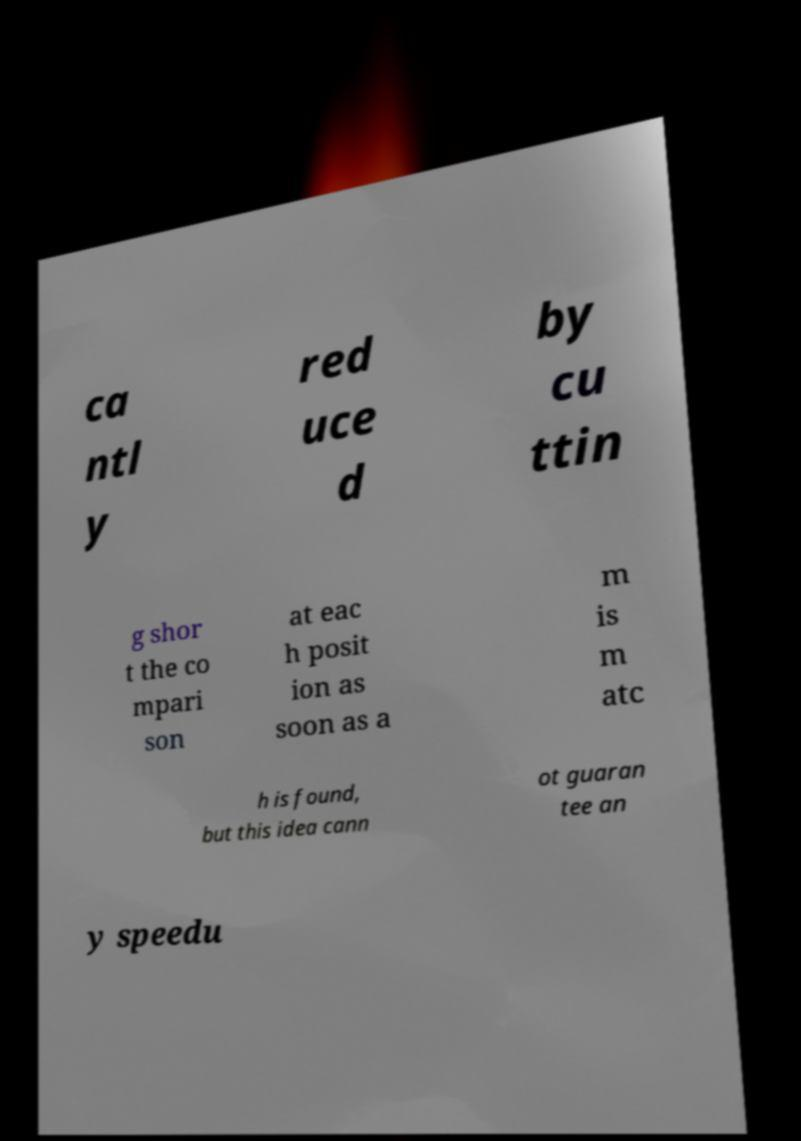I need the written content from this picture converted into text. Can you do that? ca ntl y red uce d by cu ttin g shor t the co mpari son at eac h posit ion as soon as a m is m atc h is found, but this idea cann ot guaran tee an y speedu 